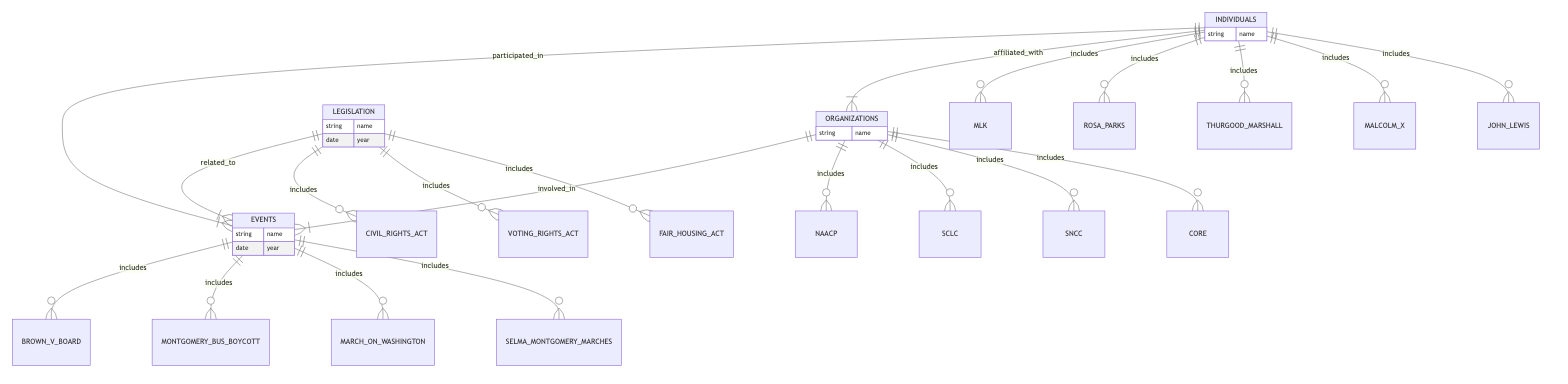What organizations were involved in the Montgomery Bus Boycott? The diagram shows that the NAACP was the organization involved in the Montgomery Bus Boycott event. This information is found by looking at the "Organizations_Involvement_In_Events" relationship.
Answer: NAACP Which legislation is related to the Selma to Montgomery Marches? The diagram indicates that the Voting Rights Act of 1965 is related to the Selma to Montgomery Marches. This can be deduced from the "Legislation_Related_Events" relationship listing the Voting Rights Act along with the matching event.
Answer: Voting Rights Act of 1965 How many individuals participated in the March on Washington? According to the diagram, two individuals—Martin Luther King Jr. and John Lewis—participated in the March on Washington event. This is derived from the "Individuals_Involvement_In_Events" section showing these two individuals linked to this event.
Answer: 2 Which organization is John Lewis affiliated with? The diagram specifies that John Lewis is affiliated with the Student Nonviolent Coordinating Committee (SNCC). This information is found in the "Individuals_Affiliations_With_Organizations" relation listing John Lewis and SNCC.
Answer: SNCC What event is associated with the Civil Rights Act of 1964? The diagram illustrates that the March on Washington is the event associated with the Civil Rights Act of 1964. This is evident from the "Legislation_Related_Events" section linking the Act to the event.
Answer: March on Washington Which individual was involved in the Selma to Montgomery Marches? The diagram shows that John Lewis was the individual who participated in the Selma to Montgomery Marches. This can be verified through the "Individuals_Involvement_In_Events" relationship that mentions John Lewis in connection with this event.
Answer: John Lewis How many organizations are represented in the diagram? The diagram lists four organizations: NAACP, SCLC, SNCC, and CORE. Counting these entities will provide the total number represented.
Answer: 4 What is the significant court case depicted in the events? The significant court case shown in the diagram is Brown v. Board of Education (1954). This can be found in the events section, where this court case is explicitly named.
Answer: Brown v. Board of Education What organization is Thurgood Marshall affiliated with? The diagram indicates that Thurgood Marshall is affiliated with the NAACP. This relationship is detailed in the "Individuals_Affiliations_With_Organizations" section.
Answer: NAACP 